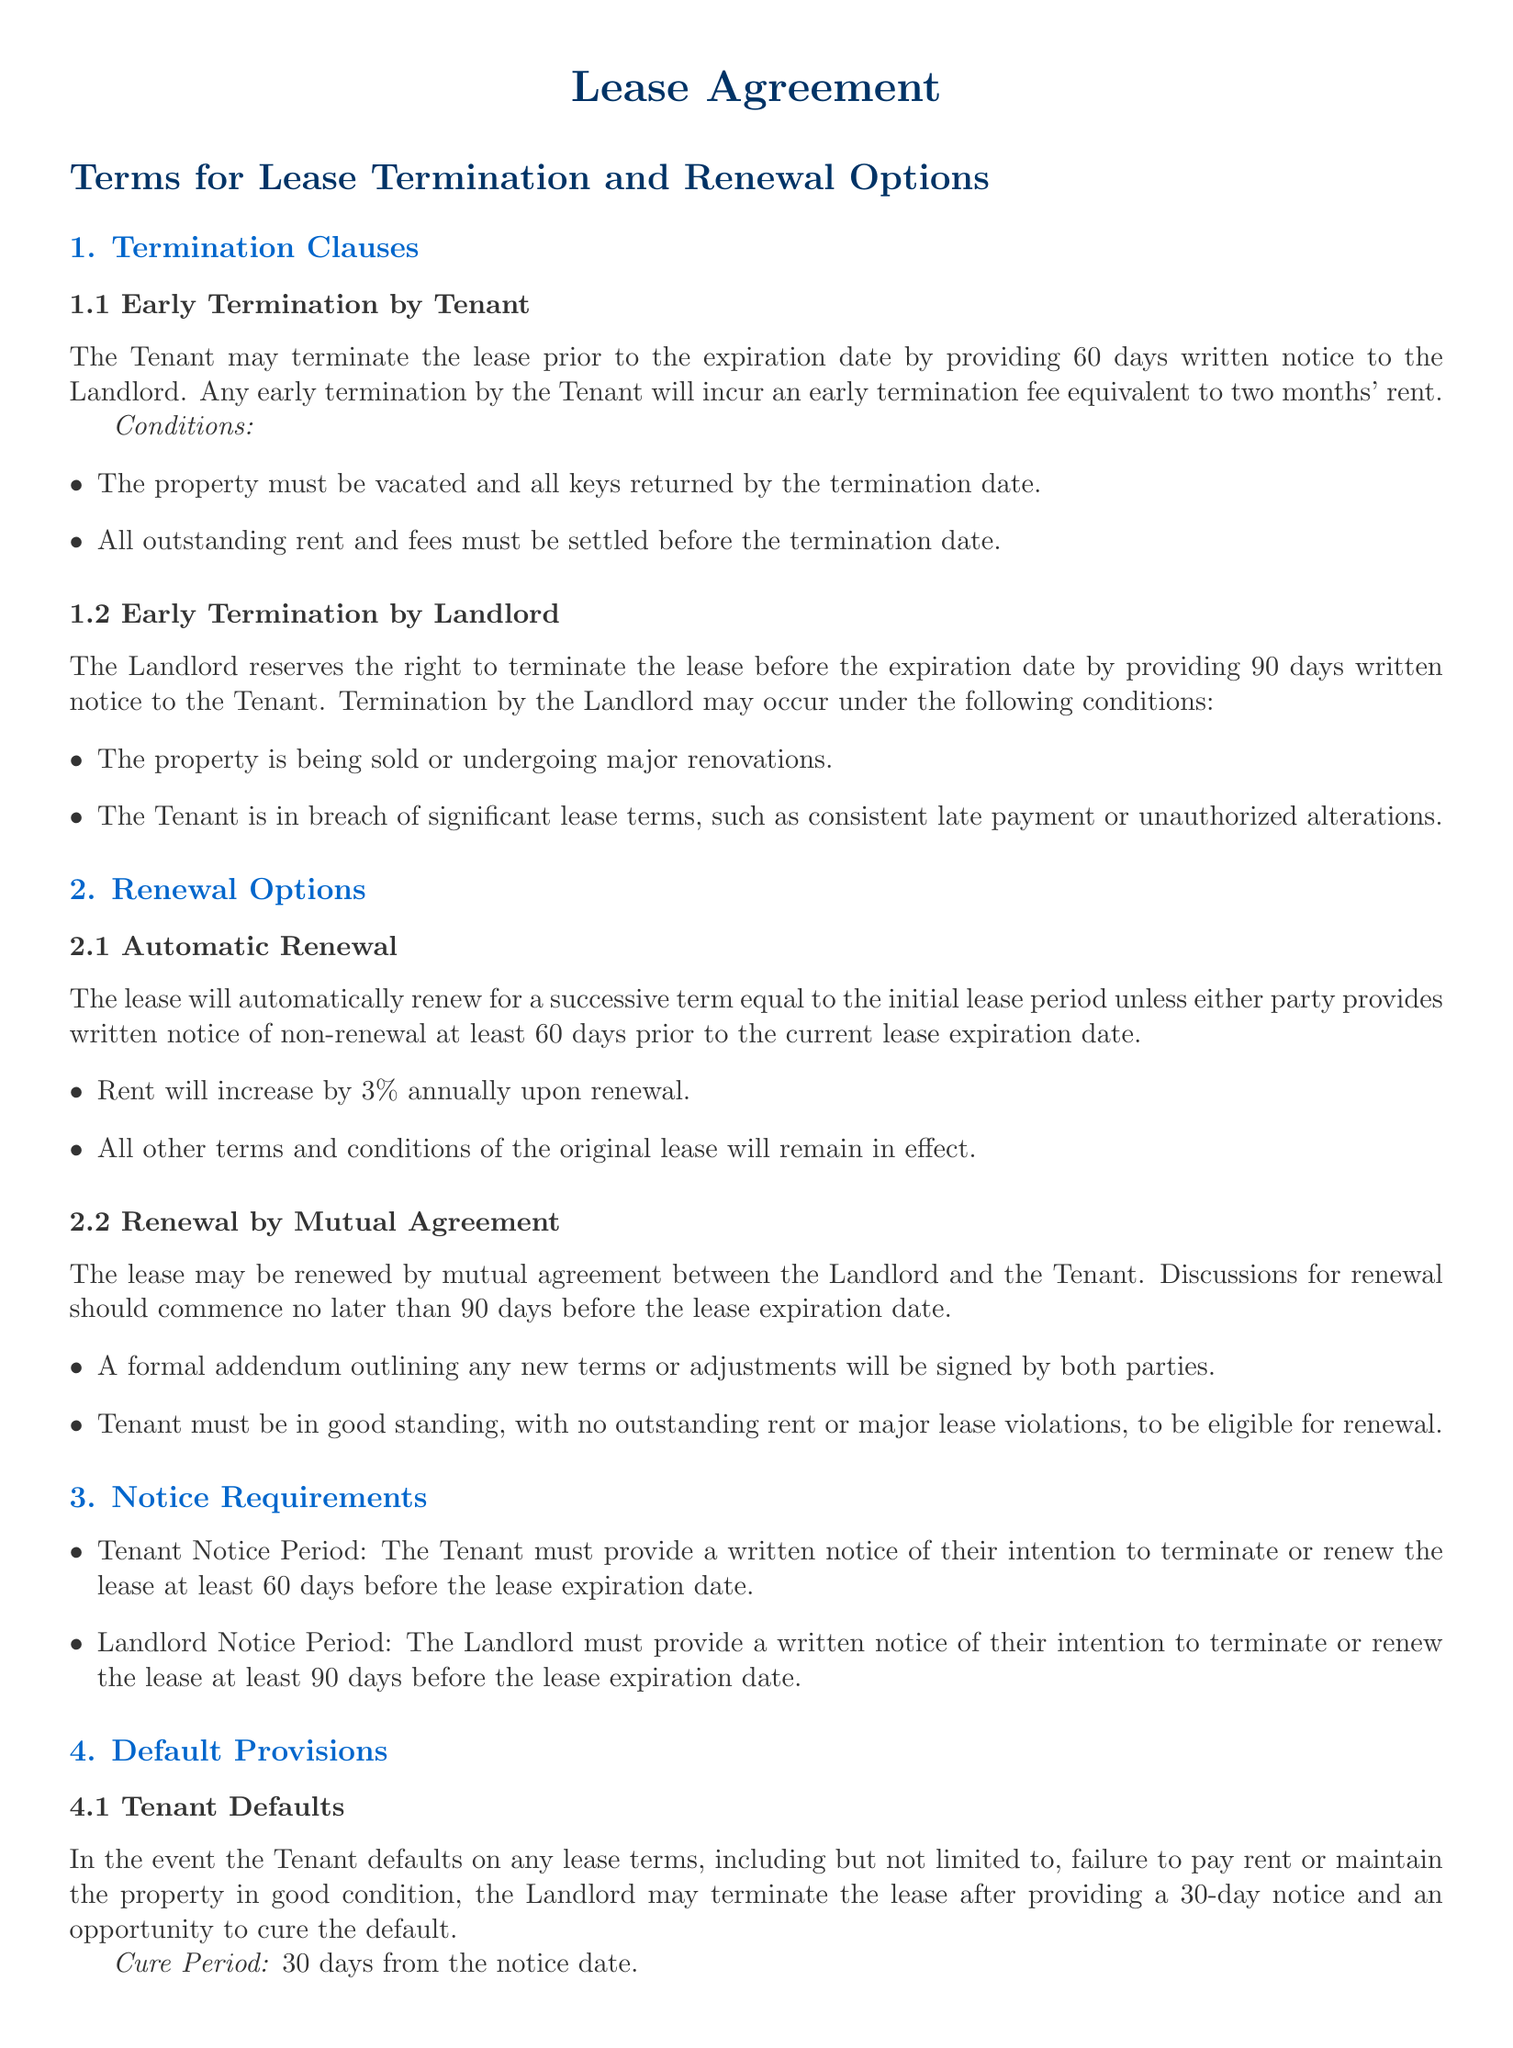What is the notice period required for early termination by the Tenant? The Tenant must provide a written notice of 60 days for early termination.
Answer: 60 days What is the early termination fee for the Tenant? The early termination fee incurred by the Tenant is equivalent to two months' rent.
Answer: Two months' rent How many days' notice must the Landlord provide for early termination? The Landlord must provide written notice of 90 days for early termination.
Answer: 90 days What is the annual rent increase upon automatic renewal? The rent will increase by 3% annually upon renewal.
Answer: 3% What must occur before the Tenant is eligible for lease renewal by mutual agreement? The Tenant must be in good standing, with no outstanding rent or major lease violations.
Answer: Good standing What is the cure period for Tenant defaults? The cure period for Tenant defaults is 30 days from the notice date.
Answer: 30 days Under what conditions can the Landlord terminate the lease? The Landlord can terminate the lease if the property is sold or undergoing major renovations or if the Tenant breaches significant lease terms.
Answer: Major renovations or breach When should discussions for renewal commence? Discussions for renewal should commence no later than 90 days before the lease expiration date.
Answer: 90 days 